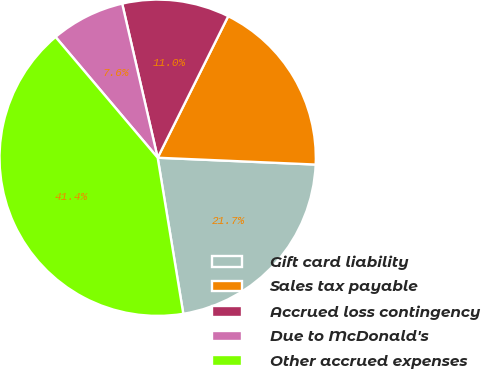Convert chart. <chart><loc_0><loc_0><loc_500><loc_500><pie_chart><fcel>Gift card liability<fcel>Sales tax payable<fcel>Accrued loss contingency<fcel>Due to McDonald's<fcel>Other accrued expenses<nl><fcel>21.72%<fcel>18.33%<fcel>10.96%<fcel>7.57%<fcel>41.42%<nl></chart> 